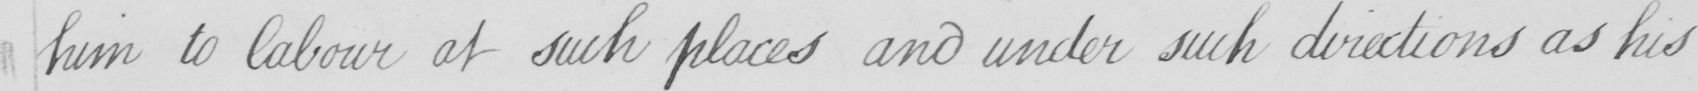Please provide the text content of this handwritten line. him to labour at such places and under such directions as his 